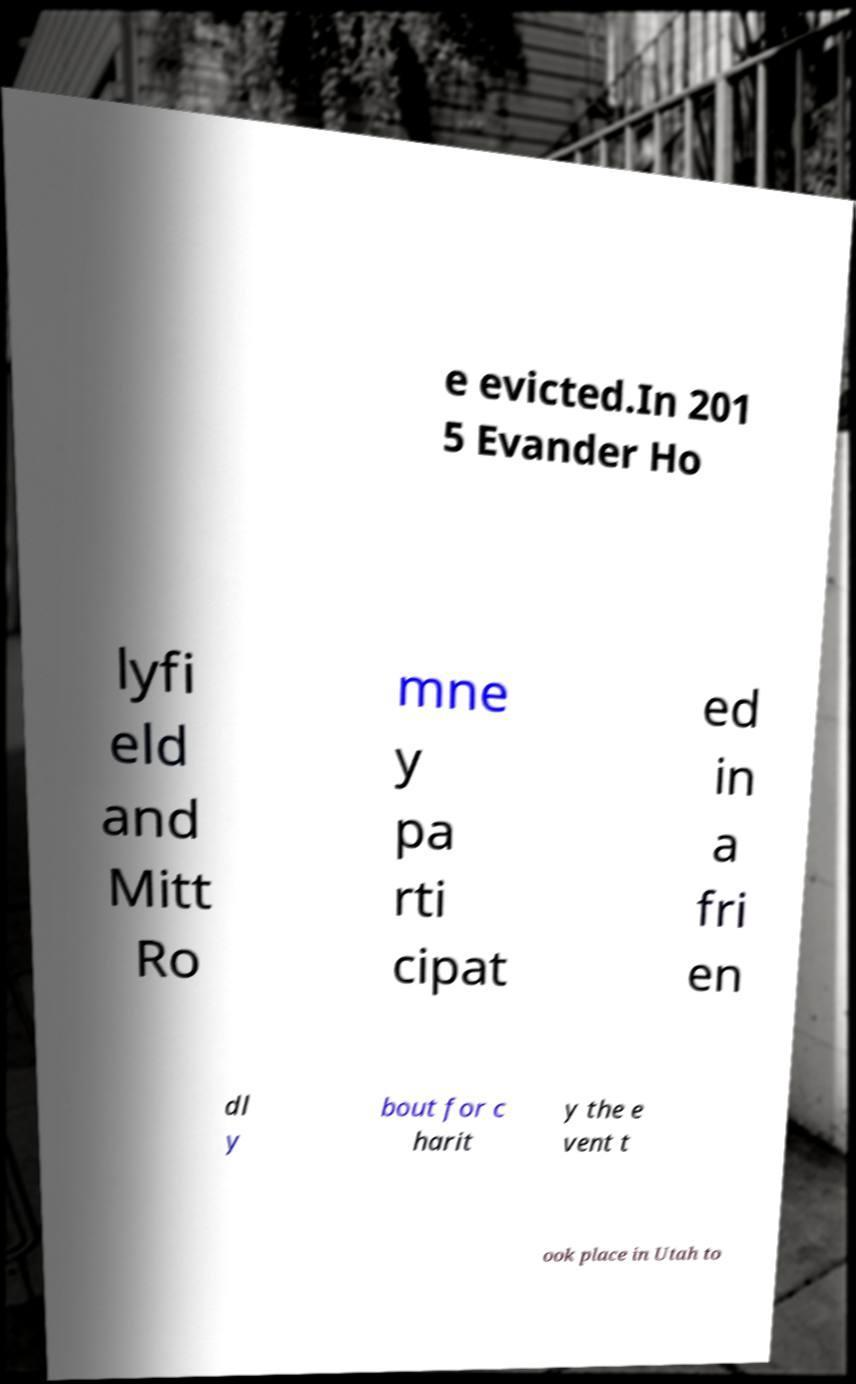Please read and relay the text visible in this image. What does it say? e evicted.In 201 5 Evander Ho lyfi eld and Mitt Ro mne y pa rti cipat ed in a fri en dl y bout for c harit y the e vent t ook place in Utah to 